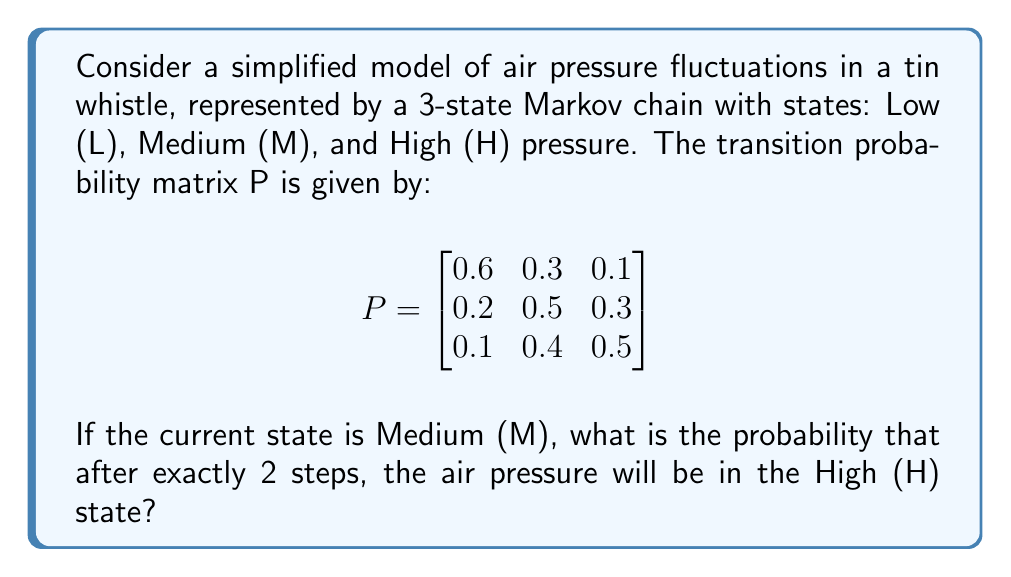Teach me how to tackle this problem. Let's approach this step-by-step:

1) We need to calculate the probability of going from state M to state H in exactly 2 steps.

2) To do this, we need to use the Chapman-Kolmogorov equations, which state that the 2-step transition probability is given by the square of the transition matrix:

   $$P^{(2)} = P^2$$

3) Let's calculate $P^2$:

   $$P^2 = \begin{bmatrix}
   0.6 & 0.3 & 0.1 \\
   0.2 & 0.5 & 0.3 \\
   0.1 & 0.4 & 0.5
   \end{bmatrix} \times \begin{bmatrix}
   0.6 & 0.3 & 0.1 \\
   0.2 & 0.5 & 0.3 \\
   0.1 & 0.4 & 0.5
   \end{bmatrix}$$

4) Performing the matrix multiplication:

   $$P^2 = \begin{bmatrix}
   0.44 & 0.39 & 0.17 \\
   0.29 & 0.44 & 0.27 \\
   0.23 & 0.46 & 0.31
   \end{bmatrix}$$

5) The probability we're looking for is the entry in the 2nd row (representing starting in state M) and 3rd column (representing ending in state H) of $P^2$.

6) This value is 0.27 or 27%.
Answer: 0.27 